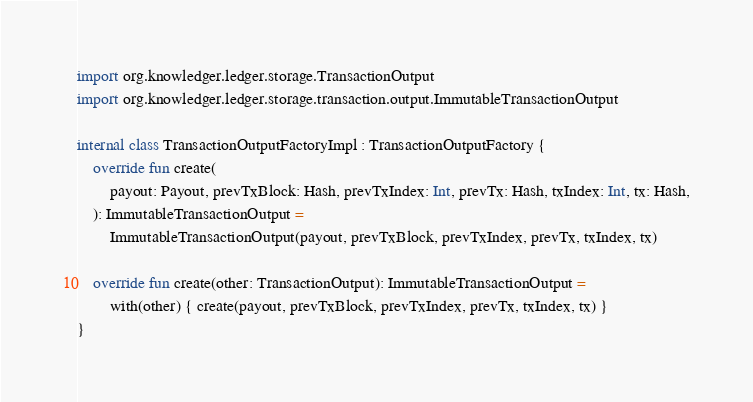<code> <loc_0><loc_0><loc_500><loc_500><_Kotlin_>import org.knowledger.ledger.storage.TransactionOutput
import org.knowledger.ledger.storage.transaction.output.ImmutableTransactionOutput

internal class TransactionOutputFactoryImpl : TransactionOutputFactory {
    override fun create(
        payout: Payout, prevTxBlock: Hash, prevTxIndex: Int, prevTx: Hash, txIndex: Int, tx: Hash,
    ): ImmutableTransactionOutput =
        ImmutableTransactionOutput(payout, prevTxBlock, prevTxIndex, prevTx, txIndex, tx)

    override fun create(other: TransactionOutput): ImmutableTransactionOutput =
        with(other) { create(payout, prevTxBlock, prevTxIndex, prevTx, txIndex, tx) }
}</code> 